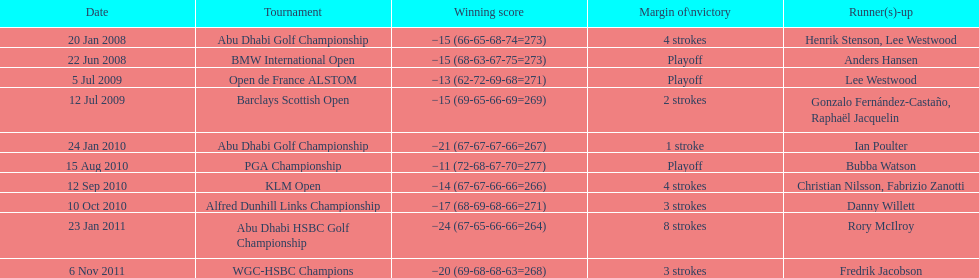How many total tournaments has he won? 10. 